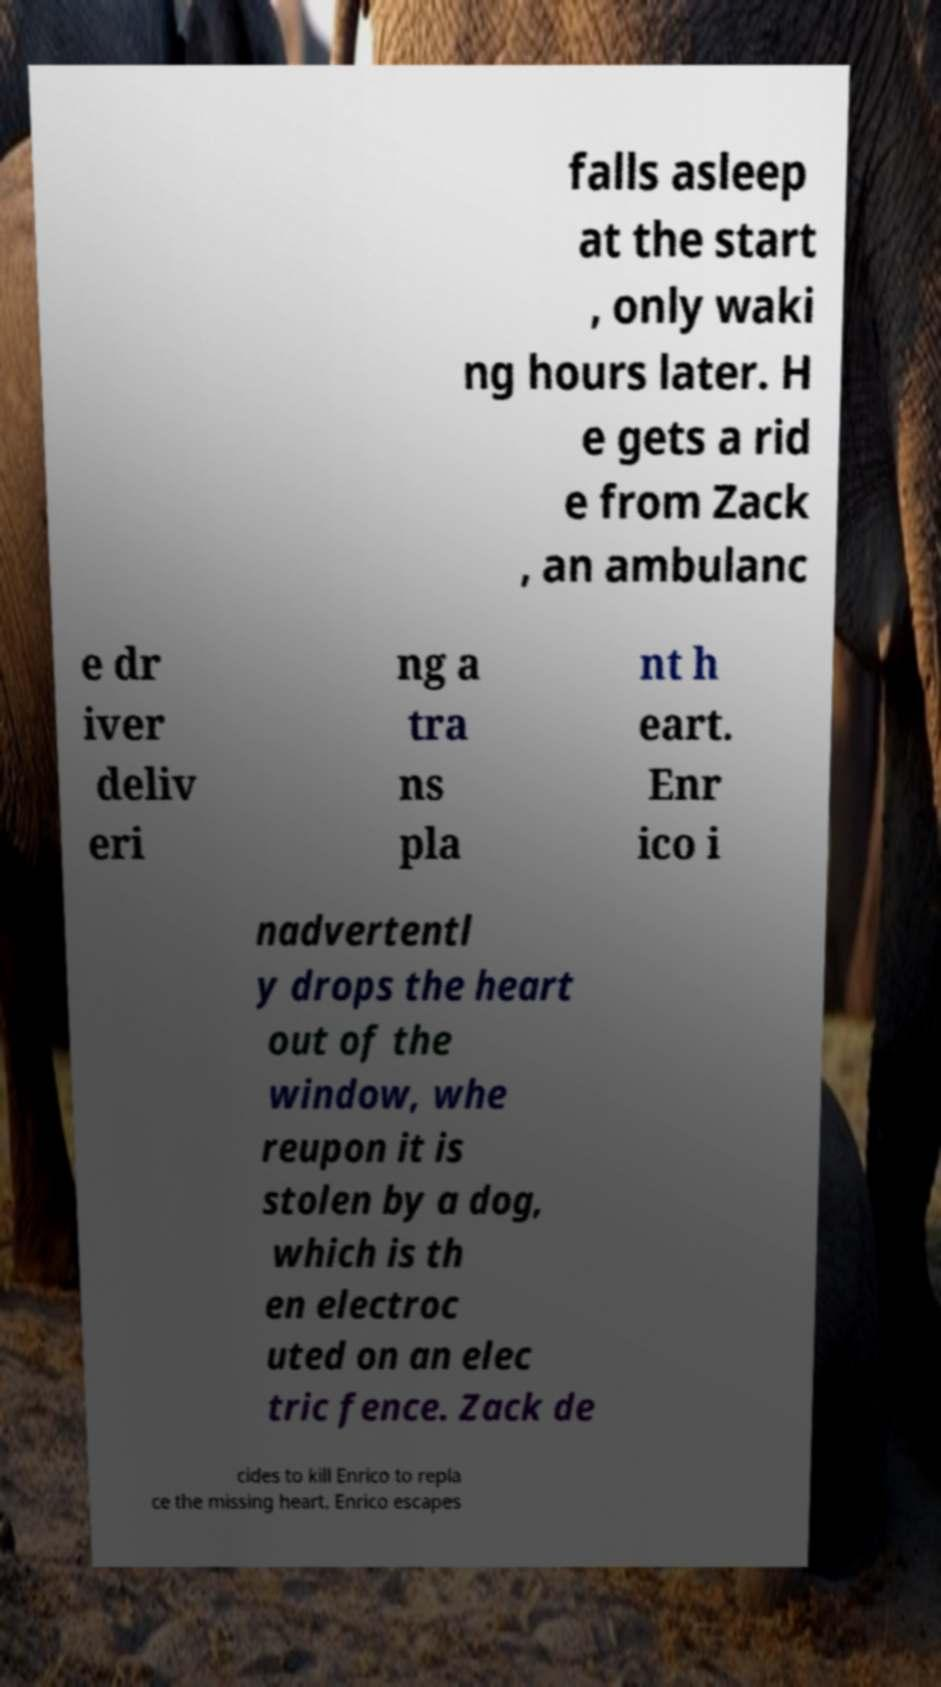What messages or text are displayed in this image? I need them in a readable, typed format. falls asleep at the start , only waki ng hours later. H e gets a rid e from Zack , an ambulanc e dr iver deliv eri ng a tra ns pla nt h eart. Enr ico i nadvertentl y drops the heart out of the window, whe reupon it is stolen by a dog, which is th en electroc uted on an elec tric fence. Zack de cides to kill Enrico to repla ce the missing heart. Enrico escapes 